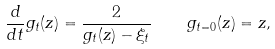Convert formula to latex. <formula><loc_0><loc_0><loc_500><loc_500>\frac { d } { d t } g _ { t } ( z ) = \frac { 2 } { g _ { t } ( z ) - \xi _ { t } } \quad g _ { t = 0 } ( z ) = z ,</formula> 